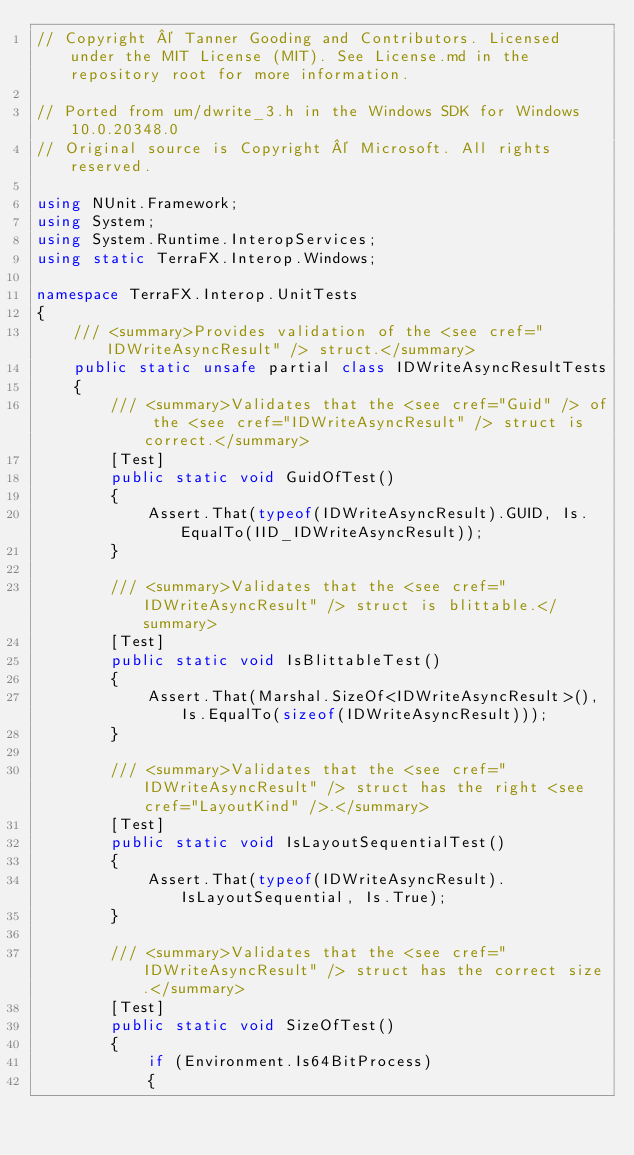Convert code to text. <code><loc_0><loc_0><loc_500><loc_500><_C#_>// Copyright © Tanner Gooding and Contributors. Licensed under the MIT License (MIT). See License.md in the repository root for more information.

// Ported from um/dwrite_3.h in the Windows SDK for Windows 10.0.20348.0
// Original source is Copyright © Microsoft. All rights reserved.

using NUnit.Framework;
using System;
using System.Runtime.InteropServices;
using static TerraFX.Interop.Windows;

namespace TerraFX.Interop.UnitTests
{
    /// <summary>Provides validation of the <see cref="IDWriteAsyncResult" /> struct.</summary>
    public static unsafe partial class IDWriteAsyncResultTests
    {
        /// <summary>Validates that the <see cref="Guid" /> of the <see cref="IDWriteAsyncResult" /> struct is correct.</summary>
        [Test]
        public static void GuidOfTest()
        {
            Assert.That(typeof(IDWriteAsyncResult).GUID, Is.EqualTo(IID_IDWriteAsyncResult));
        }

        /// <summary>Validates that the <see cref="IDWriteAsyncResult" /> struct is blittable.</summary>
        [Test]
        public static void IsBlittableTest()
        {
            Assert.That(Marshal.SizeOf<IDWriteAsyncResult>(), Is.EqualTo(sizeof(IDWriteAsyncResult)));
        }

        /// <summary>Validates that the <see cref="IDWriteAsyncResult" /> struct has the right <see cref="LayoutKind" />.</summary>
        [Test]
        public static void IsLayoutSequentialTest()
        {
            Assert.That(typeof(IDWriteAsyncResult).IsLayoutSequential, Is.True);
        }

        /// <summary>Validates that the <see cref="IDWriteAsyncResult" /> struct has the correct size.</summary>
        [Test]
        public static void SizeOfTest()
        {
            if (Environment.Is64BitProcess)
            {</code> 